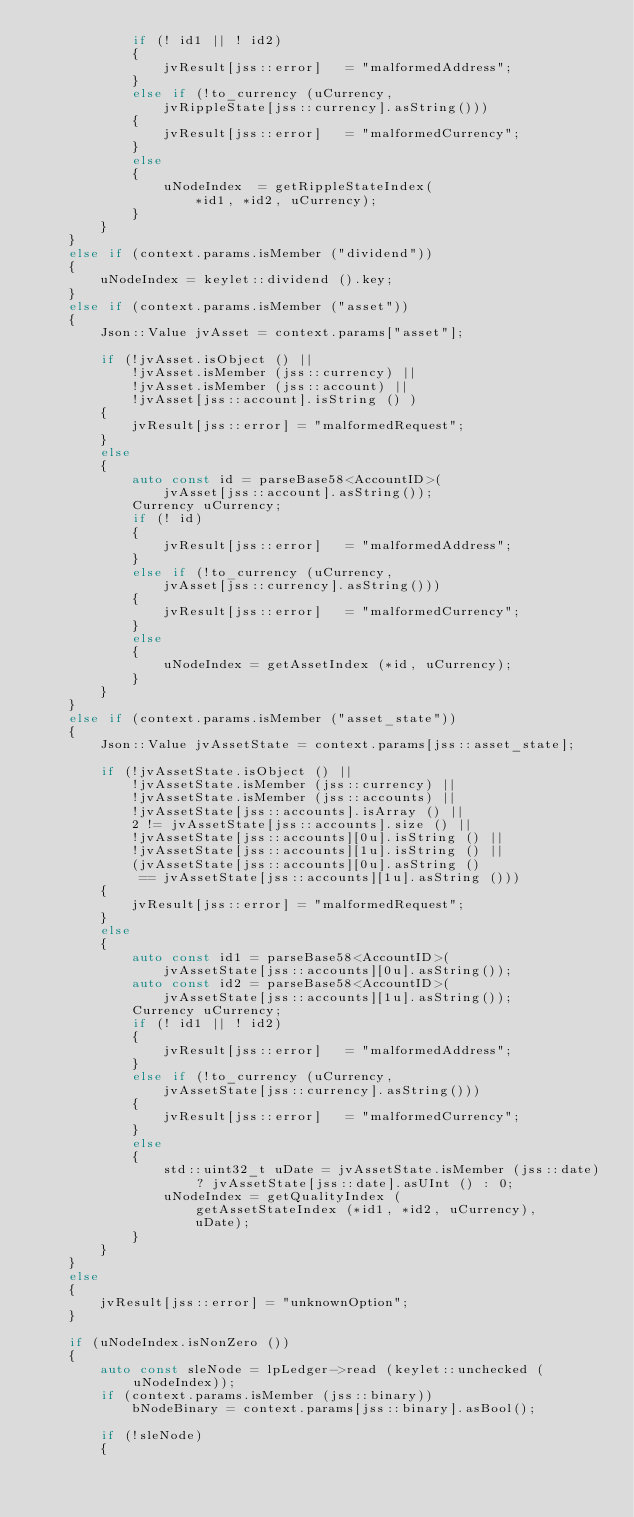<code> <loc_0><loc_0><loc_500><loc_500><_C++_>            if (! id1 || ! id2)
            {
                jvResult[jss::error]   = "malformedAddress";
            }
            else if (!to_currency (uCurrency,
                jvRippleState[jss::currency].asString()))
            {
                jvResult[jss::error]   = "malformedCurrency";
            }
            else
            {
                uNodeIndex  = getRippleStateIndex(
                    *id1, *id2, uCurrency);
            }
        }
    }
    else if (context.params.isMember ("dividend"))
    {
        uNodeIndex = keylet::dividend ().key;
    }
    else if (context.params.isMember ("asset"))
    {
        Json::Value jvAsset = context.params["asset"];

        if (!jvAsset.isObject () ||
            !jvAsset.isMember (jss::currency) ||
            !jvAsset.isMember (jss::account) ||
            !jvAsset[jss::account].isString () )
        {
            jvResult[jss::error] = "malformedRequest";
        }
        else
        {
            auto const id = parseBase58<AccountID>(
                jvAsset[jss::account].asString());
            Currency uCurrency;
            if (! id)
            {
                jvResult[jss::error]   = "malformedAddress";
            }
            else if (!to_currency (uCurrency,
                jvAsset[jss::currency].asString()))
            {
                jvResult[jss::error]   = "malformedCurrency";
            }
            else
            {
                uNodeIndex = getAssetIndex (*id, uCurrency);
            }
        }
    }
    else if (context.params.isMember ("asset_state"))
    {
        Json::Value jvAssetState = context.params[jss::asset_state];

        if (!jvAssetState.isObject () ||
            !jvAssetState.isMember (jss::currency) ||
            !jvAssetState.isMember (jss::accounts) ||
            !jvAssetState[jss::accounts].isArray () ||
            2 != jvAssetState[jss::accounts].size () ||
            !jvAssetState[jss::accounts][0u].isString () ||
            !jvAssetState[jss::accounts][1u].isString () ||
            (jvAssetState[jss::accounts][0u].asString ()
             == jvAssetState[jss::accounts][1u].asString ()))
        {
            jvResult[jss::error] = "malformedRequest";
        }
        else
        {
            auto const id1 = parseBase58<AccountID>(
                jvAssetState[jss::accounts][0u].asString());
            auto const id2 = parseBase58<AccountID>(
                jvAssetState[jss::accounts][1u].asString());
            Currency uCurrency;
            if (! id1 || ! id2)
            {
                jvResult[jss::error]   = "malformedAddress";
            }
            else if (!to_currency (uCurrency,
                jvAssetState[jss::currency].asString()))
            {
                jvResult[jss::error]   = "malformedCurrency";
            }
            else
            {
                std::uint32_t uDate = jvAssetState.isMember (jss::date) ? jvAssetState[jss::date].asUInt () : 0;
                uNodeIndex = getQualityIndex (
                    getAssetStateIndex (*id1, *id2, uCurrency),
                    uDate);
            }
        }
    }
    else
    {
        jvResult[jss::error] = "unknownOption";
    }

    if (uNodeIndex.isNonZero ())
    {
        auto const sleNode = lpLedger->read (keylet::unchecked (uNodeIndex));
        if (context.params.isMember (jss::binary))
            bNodeBinary = context.params[jss::binary].asBool();

        if (!sleNode)
        {</code> 